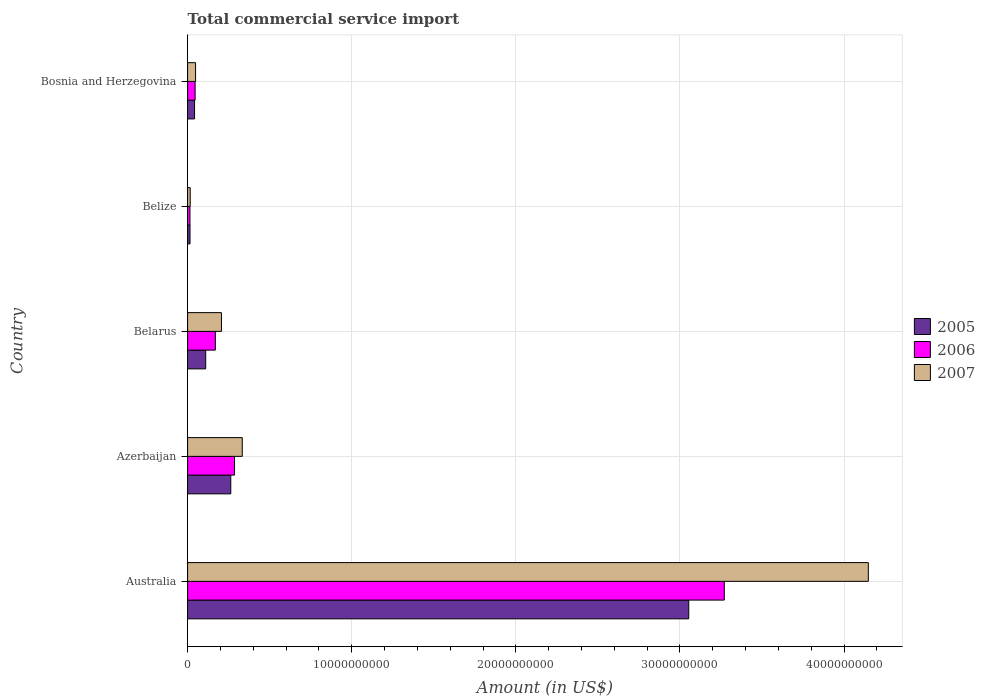How many groups of bars are there?
Offer a very short reply. 5. Are the number of bars on each tick of the Y-axis equal?
Your answer should be compact. Yes. How many bars are there on the 1st tick from the top?
Offer a terse response. 3. What is the label of the 2nd group of bars from the top?
Keep it short and to the point. Belize. In how many cases, is the number of bars for a given country not equal to the number of legend labels?
Make the answer very short. 0. What is the total commercial service import in 2005 in Bosnia and Herzegovina?
Your answer should be very brief. 4.25e+08. Across all countries, what is the maximum total commercial service import in 2007?
Give a very brief answer. 4.15e+1. Across all countries, what is the minimum total commercial service import in 2005?
Offer a very short reply. 1.47e+08. In which country was the total commercial service import in 2006 maximum?
Offer a terse response. Australia. In which country was the total commercial service import in 2007 minimum?
Provide a succinct answer. Belize. What is the total total commercial service import in 2005 in the graph?
Provide a short and direct response. 3.48e+1. What is the difference between the total commercial service import in 2005 in Azerbaijan and that in Bosnia and Herzegovina?
Offer a very short reply. 2.21e+09. What is the difference between the total commercial service import in 2007 in Belize and the total commercial service import in 2006 in Azerbaijan?
Offer a terse response. -2.70e+09. What is the average total commercial service import in 2005 per country?
Your answer should be very brief. 6.97e+09. What is the difference between the total commercial service import in 2005 and total commercial service import in 2007 in Azerbaijan?
Your answer should be compact. -7.00e+08. In how many countries, is the total commercial service import in 2006 greater than 10000000000 US$?
Offer a terse response. 1. What is the ratio of the total commercial service import in 2006 in Australia to that in Bosnia and Herzegovina?
Offer a terse response. 71.39. Is the total commercial service import in 2005 in Belarus less than that in Bosnia and Herzegovina?
Keep it short and to the point. No. What is the difference between the highest and the second highest total commercial service import in 2005?
Give a very brief answer. 2.79e+1. What is the difference between the highest and the lowest total commercial service import in 2005?
Ensure brevity in your answer.  3.04e+1. Is the sum of the total commercial service import in 2006 in Australia and Belarus greater than the maximum total commercial service import in 2005 across all countries?
Make the answer very short. Yes. How many bars are there?
Your answer should be very brief. 15. What is the difference between two consecutive major ticks on the X-axis?
Your answer should be compact. 1.00e+1. Does the graph contain any zero values?
Offer a very short reply. No. Does the graph contain grids?
Make the answer very short. Yes. How many legend labels are there?
Ensure brevity in your answer.  3. What is the title of the graph?
Keep it short and to the point. Total commercial service import. What is the label or title of the X-axis?
Provide a succinct answer. Amount (in US$). What is the Amount (in US$) of 2005 in Australia?
Offer a very short reply. 3.05e+1. What is the Amount (in US$) of 2006 in Australia?
Ensure brevity in your answer.  3.27e+1. What is the Amount (in US$) in 2007 in Australia?
Ensure brevity in your answer.  4.15e+1. What is the Amount (in US$) in 2005 in Azerbaijan?
Provide a short and direct response. 2.63e+09. What is the Amount (in US$) in 2006 in Azerbaijan?
Your answer should be very brief. 2.86e+09. What is the Amount (in US$) in 2007 in Azerbaijan?
Keep it short and to the point. 3.33e+09. What is the Amount (in US$) of 2005 in Belarus?
Give a very brief answer. 1.10e+09. What is the Amount (in US$) in 2006 in Belarus?
Make the answer very short. 1.69e+09. What is the Amount (in US$) in 2007 in Belarus?
Make the answer very short. 2.06e+09. What is the Amount (in US$) in 2005 in Belize?
Keep it short and to the point. 1.47e+08. What is the Amount (in US$) of 2006 in Belize?
Provide a short and direct response. 1.43e+08. What is the Amount (in US$) in 2007 in Belize?
Offer a very short reply. 1.59e+08. What is the Amount (in US$) in 2005 in Bosnia and Herzegovina?
Make the answer very short. 4.25e+08. What is the Amount (in US$) of 2006 in Bosnia and Herzegovina?
Your answer should be very brief. 4.58e+08. What is the Amount (in US$) in 2007 in Bosnia and Herzegovina?
Provide a short and direct response. 4.87e+08. Across all countries, what is the maximum Amount (in US$) of 2005?
Your answer should be very brief. 3.05e+1. Across all countries, what is the maximum Amount (in US$) in 2006?
Make the answer very short. 3.27e+1. Across all countries, what is the maximum Amount (in US$) of 2007?
Give a very brief answer. 4.15e+1. Across all countries, what is the minimum Amount (in US$) of 2005?
Offer a terse response. 1.47e+08. Across all countries, what is the minimum Amount (in US$) in 2006?
Give a very brief answer. 1.43e+08. Across all countries, what is the minimum Amount (in US$) of 2007?
Ensure brevity in your answer.  1.59e+08. What is the total Amount (in US$) in 2005 in the graph?
Keep it short and to the point. 3.48e+1. What is the total Amount (in US$) in 2006 in the graph?
Give a very brief answer. 3.79e+1. What is the total Amount (in US$) of 2007 in the graph?
Make the answer very short. 4.75e+1. What is the difference between the Amount (in US$) of 2005 in Australia and that in Azerbaijan?
Ensure brevity in your answer.  2.79e+1. What is the difference between the Amount (in US$) in 2006 in Australia and that in Azerbaijan?
Provide a succinct answer. 2.98e+1. What is the difference between the Amount (in US$) in 2007 in Australia and that in Azerbaijan?
Your answer should be very brief. 3.81e+1. What is the difference between the Amount (in US$) of 2005 in Australia and that in Belarus?
Your answer should be compact. 2.94e+1. What is the difference between the Amount (in US$) in 2006 in Australia and that in Belarus?
Your answer should be compact. 3.10e+1. What is the difference between the Amount (in US$) of 2007 in Australia and that in Belarus?
Offer a terse response. 3.94e+1. What is the difference between the Amount (in US$) of 2005 in Australia and that in Belize?
Keep it short and to the point. 3.04e+1. What is the difference between the Amount (in US$) in 2006 in Australia and that in Belize?
Make the answer very short. 3.26e+1. What is the difference between the Amount (in US$) in 2007 in Australia and that in Belize?
Make the answer very short. 4.13e+1. What is the difference between the Amount (in US$) in 2005 in Australia and that in Bosnia and Herzegovina?
Offer a terse response. 3.01e+1. What is the difference between the Amount (in US$) of 2006 in Australia and that in Bosnia and Herzegovina?
Provide a succinct answer. 3.22e+1. What is the difference between the Amount (in US$) of 2007 in Australia and that in Bosnia and Herzegovina?
Make the answer very short. 4.10e+1. What is the difference between the Amount (in US$) in 2005 in Azerbaijan and that in Belarus?
Your answer should be very brief. 1.53e+09. What is the difference between the Amount (in US$) in 2006 in Azerbaijan and that in Belarus?
Your response must be concise. 1.17e+09. What is the difference between the Amount (in US$) in 2007 in Azerbaijan and that in Belarus?
Provide a short and direct response. 1.27e+09. What is the difference between the Amount (in US$) in 2005 in Azerbaijan and that in Belize?
Keep it short and to the point. 2.48e+09. What is the difference between the Amount (in US$) of 2006 in Azerbaijan and that in Belize?
Offer a very short reply. 2.72e+09. What is the difference between the Amount (in US$) in 2007 in Azerbaijan and that in Belize?
Make the answer very short. 3.17e+09. What is the difference between the Amount (in US$) in 2005 in Azerbaijan and that in Bosnia and Herzegovina?
Your answer should be very brief. 2.21e+09. What is the difference between the Amount (in US$) in 2006 in Azerbaijan and that in Bosnia and Herzegovina?
Your answer should be very brief. 2.40e+09. What is the difference between the Amount (in US$) in 2007 in Azerbaijan and that in Bosnia and Herzegovina?
Offer a terse response. 2.84e+09. What is the difference between the Amount (in US$) of 2005 in Belarus and that in Belize?
Offer a terse response. 9.57e+08. What is the difference between the Amount (in US$) of 2006 in Belarus and that in Belize?
Offer a terse response. 1.55e+09. What is the difference between the Amount (in US$) of 2007 in Belarus and that in Belize?
Your answer should be very brief. 1.90e+09. What is the difference between the Amount (in US$) of 2005 in Belarus and that in Bosnia and Herzegovina?
Make the answer very short. 6.79e+08. What is the difference between the Amount (in US$) of 2006 in Belarus and that in Bosnia and Herzegovina?
Your answer should be very brief. 1.23e+09. What is the difference between the Amount (in US$) of 2007 in Belarus and that in Bosnia and Herzegovina?
Your response must be concise. 1.58e+09. What is the difference between the Amount (in US$) of 2005 in Belize and that in Bosnia and Herzegovina?
Your answer should be very brief. -2.78e+08. What is the difference between the Amount (in US$) in 2006 in Belize and that in Bosnia and Herzegovina?
Your answer should be compact. -3.15e+08. What is the difference between the Amount (in US$) in 2007 in Belize and that in Bosnia and Herzegovina?
Your answer should be very brief. -3.28e+08. What is the difference between the Amount (in US$) of 2005 in Australia and the Amount (in US$) of 2006 in Azerbaijan?
Ensure brevity in your answer.  2.77e+1. What is the difference between the Amount (in US$) in 2005 in Australia and the Amount (in US$) in 2007 in Azerbaijan?
Offer a terse response. 2.72e+1. What is the difference between the Amount (in US$) of 2006 in Australia and the Amount (in US$) of 2007 in Azerbaijan?
Provide a succinct answer. 2.94e+1. What is the difference between the Amount (in US$) in 2005 in Australia and the Amount (in US$) in 2006 in Belarus?
Provide a short and direct response. 2.88e+1. What is the difference between the Amount (in US$) of 2005 in Australia and the Amount (in US$) of 2007 in Belarus?
Offer a very short reply. 2.85e+1. What is the difference between the Amount (in US$) of 2006 in Australia and the Amount (in US$) of 2007 in Belarus?
Your response must be concise. 3.06e+1. What is the difference between the Amount (in US$) of 2005 in Australia and the Amount (in US$) of 2006 in Belize?
Give a very brief answer. 3.04e+1. What is the difference between the Amount (in US$) in 2005 in Australia and the Amount (in US$) in 2007 in Belize?
Offer a terse response. 3.04e+1. What is the difference between the Amount (in US$) in 2006 in Australia and the Amount (in US$) in 2007 in Belize?
Ensure brevity in your answer.  3.25e+1. What is the difference between the Amount (in US$) in 2005 in Australia and the Amount (in US$) in 2006 in Bosnia and Herzegovina?
Ensure brevity in your answer.  3.01e+1. What is the difference between the Amount (in US$) of 2005 in Australia and the Amount (in US$) of 2007 in Bosnia and Herzegovina?
Keep it short and to the point. 3.00e+1. What is the difference between the Amount (in US$) of 2006 in Australia and the Amount (in US$) of 2007 in Bosnia and Herzegovina?
Provide a succinct answer. 3.22e+1. What is the difference between the Amount (in US$) in 2005 in Azerbaijan and the Amount (in US$) in 2006 in Belarus?
Ensure brevity in your answer.  9.40e+08. What is the difference between the Amount (in US$) in 2005 in Azerbaijan and the Amount (in US$) in 2007 in Belarus?
Ensure brevity in your answer.  5.68e+08. What is the difference between the Amount (in US$) in 2006 in Azerbaijan and the Amount (in US$) in 2007 in Belarus?
Offer a very short reply. 7.97e+08. What is the difference between the Amount (in US$) in 2005 in Azerbaijan and the Amount (in US$) in 2006 in Belize?
Your answer should be very brief. 2.49e+09. What is the difference between the Amount (in US$) in 2005 in Azerbaijan and the Amount (in US$) in 2007 in Belize?
Offer a terse response. 2.47e+09. What is the difference between the Amount (in US$) of 2006 in Azerbaijan and the Amount (in US$) of 2007 in Belize?
Offer a terse response. 2.70e+09. What is the difference between the Amount (in US$) of 2005 in Azerbaijan and the Amount (in US$) of 2006 in Bosnia and Herzegovina?
Your answer should be very brief. 2.17e+09. What is the difference between the Amount (in US$) in 2005 in Azerbaijan and the Amount (in US$) in 2007 in Bosnia and Herzegovina?
Ensure brevity in your answer.  2.14e+09. What is the difference between the Amount (in US$) in 2006 in Azerbaijan and the Amount (in US$) in 2007 in Bosnia and Herzegovina?
Make the answer very short. 2.37e+09. What is the difference between the Amount (in US$) of 2005 in Belarus and the Amount (in US$) of 2006 in Belize?
Provide a succinct answer. 9.61e+08. What is the difference between the Amount (in US$) of 2005 in Belarus and the Amount (in US$) of 2007 in Belize?
Offer a very short reply. 9.45e+08. What is the difference between the Amount (in US$) of 2006 in Belarus and the Amount (in US$) of 2007 in Belize?
Keep it short and to the point. 1.53e+09. What is the difference between the Amount (in US$) in 2005 in Belarus and the Amount (in US$) in 2006 in Bosnia and Herzegovina?
Keep it short and to the point. 6.46e+08. What is the difference between the Amount (in US$) of 2005 in Belarus and the Amount (in US$) of 2007 in Bosnia and Herzegovina?
Give a very brief answer. 6.18e+08. What is the difference between the Amount (in US$) of 2006 in Belarus and the Amount (in US$) of 2007 in Bosnia and Herzegovina?
Give a very brief answer. 1.20e+09. What is the difference between the Amount (in US$) in 2005 in Belize and the Amount (in US$) in 2006 in Bosnia and Herzegovina?
Provide a short and direct response. -3.11e+08. What is the difference between the Amount (in US$) of 2005 in Belize and the Amount (in US$) of 2007 in Bosnia and Herzegovina?
Offer a very short reply. -3.39e+08. What is the difference between the Amount (in US$) of 2006 in Belize and the Amount (in US$) of 2007 in Bosnia and Herzegovina?
Offer a terse response. -3.43e+08. What is the average Amount (in US$) in 2005 per country?
Provide a short and direct response. 6.97e+09. What is the average Amount (in US$) of 2006 per country?
Your answer should be compact. 7.57e+09. What is the average Amount (in US$) in 2007 per country?
Provide a short and direct response. 9.50e+09. What is the difference between the Amount (in US$) of 2005 and Amount (in US$) of 2006 in Australia?
Your response must be concise. -2.17e+09. What is the difference between the Amount (in US$) in 2005 and Amount (in US$) in 2007 in Australia?
Keep it short and to the point. -1.09e+1. What is the difference between the Amount (in US$) in 2006 and Amount (in US$) in 2007 in Australia?
Keep it short and to the point. -8.78e+09. What is the difference between the Amount (in US$) of 2005 and Amount (in US$) of 2006 in Azerbaijan?
Make the answer very short. -2.28e+08. What is the difference between the Amount (in US$) in 2005 and Amount (in US$) in 2007 in Azerbaijan?
Your answer should be compact. -7.00e+08. What is the difference between the Amount (in US$) in 2006 and Amount (in US$) in 2007 in Azerbaijan?
Your answer should be very brief. -4.72e+08. What is the difference between the Amount (in US$) of 2005 and Amount (in US$) of 2006 in Belarus?
Make the answer very short. -5.87e+08. What is the difference between the Amount (in US$) of 2005 and Amount (in US$) of 2007 in Belarus?
Your response must be concise. -9.58e+08. What is the difference between the Amount (in US$) of 2006 and Amount (in US$) of 2007 in Belarus?
Offer a terse response. -3.72e+08. What is the difference between the Amount (in US$) in 2005 and Amount (in US$) in 2006 in Belize?
Keep it short and to the point. 3.89e+06. What is the difference between the Amount (in US$) of 2005 and Amount (in US$) of 2007 in Belize?
Provide a succinct answer. -1.18e+07. What is the difference between the Amount (in US$) in 2006 and Amount (in US$) in 2007 in Belize?
Provide a succinct answer. -1.57e+07. What is the difference between the Amount (in US$) of 2005 and Amount (in US$) of 2006 in Bosnia and Herzegovina?
Keep it short and to the point. -3.32e+07. What is the difference between the Amount (in US$) in 2005 and Amount (in US$) in 2007 in Bosnia and Herzegovina?
Provide a succinct answer. -6.18e+07. What is the difference between the Amount (in US$) in 2006 and Amount (in US$) in 2007 in Bosnia and Herzegovina?
Ensure brevity in your answer.  -2.86e+07. What is the ratio of the Amount (in US$) of 2005 in Australia to that in Azerbaijan?
Give a very brief answer. 11.61. What is the ratio of the Amount (in US$) of 2006 in Australia to that in Azerbaijan?
Give a very brief answer. 11.44. What is the ratio of the Amount (in US$) in 2007 in Australia to that in Azerbaijan?
Your response must be concise. 12.45. What is the ratio of the Amount (in US$) in 2005 in Australia to that in Belarus?
Your response must be concise. 27.65. What is the ratio of the Amount (in US$) of 2006 in Australia to that in Belarus?
Your answer should be compact. 19.34. What is the ratio of the Amount (in US$) in 2007 in Australia to that in Belarus?
Provide a short and direct response. 20.11. What is the ratio of the Amount (in US$) in 2005 in Australia to that in Belize?
Your answer should be compact. 207.45. What is the ratio of the Amount (in US$) in 2006 in Australia to that in Belize?
Your answer should be very brief. 228.19. What is the ratio of the Amount (in US$) of 2007 in Australia to that in Belize?
Your answer should be compact. 260.86. What is the ratio of the Amount (in US$) in 2005 in Australia to that in Bosnia and Herzegovina?
Keep it short and to the point. 71.87. What is the ratio of the Amount (in US$) in 2006 in Australia to that in Bosnia and Herzegovina?
Give a very brief answer. 71.39. What is the ratio of the Amount (in US$) of 2007 in Australia to that in Bosnia and Herzegovina?
Your answer should be compact. 85.23. What is the ratio of the Amount (in US$) in 2005 in Azerbaijan to that in Belarus?
Give a very brief answer. 2.38. What is the ratio of the Amount (in US$) of 2006 in Azerbaijan to that in Belarus?
Your answer should be very brief. 1.69. What is the ratio of the Amount (in US$) in 2007 in Azerbaijan to that in Belarus?
Your answer should be very brief. 1.61. What is the ratio of the Amount (in US$) in 2005 in Azerbaijan to that in Belize?
Offer a terse response. 17.87. What is the ratio of the Amount (in US$) of 2006 in Azerbaijan to that in Belize?
Provide a succinct answer. 19.95. What is the ratio of the Amount (in US$) in 2007 in Azerbaijan to that in Belize?
Offer a very short reply. 20.95. What is the ratio of the Amount (in US$) of 2005 in Azerbaijan to that in Bosnia and Herzegovina?
Ensure brevity in your answer.  6.19. What is the ratio of the Amount (in US$) of 2006 in Azerbaijan to that in Bosnia and Herzegovina?
Provide a succinct answer. 6.24. What is the ratio of the Amount (in US$) of 2007 in Azerbaijan to that in Bosnia and Herzegovina?
Your response must be concise. 6.85. What is the ratio of the Amount (in US$) in 2005 in Belarus to that in Belize?
Keep it short and to the point. 7.5. What is the ratio of the Amount (in US$) in 2006 in Belarus to that in Belize?
Provide a succinct answer. 11.8. What is the ratio of the Amount (in US$) in 2007 in Belarus to that in Belize?
Your answer should be very brief. 12.97. What is the ratio of the Amount (in US$) of 2005 in Belarus to that in Bosnia and Herzegovina?
Your answer should be very brief. 2.6. What is the ratio of the Amount (in US$) in 2006 in Belarus to that in Bosnia and Herzegovina?
Offer a very short reply. 3.69. What is the ratio of the Amount (in US$) of 2007 in Belarus to that in Bosnia and Herzegovina?
Offer a very short reply. 4.24. What is the ratio of the Amount (in US$) of 2005 in Belize to that in Bosnia and Herzegovina?
Make the answer very short. 0.35. What is the ratio of the Amount (in US$) of 2006 in Belize to that in Bosnia and Herzegovina?
Your answer should be very brief. 0.31. What is the ratio of the Amount (in US$) in 2007 in Belize to that in Bosnia and Herzegovina?
Make the answer very short. 0.33. What is the difference between the highest and the second highest Amount (in US$) of 2005?
Keep it short and to the point. 2.79e+1. What is the difference between the highest and the second highest Amount (in US$) of 2006?
Offer a terse response. 2.98e+1. What is the difference between the highest and the second highest Amount (in US$) in 2007?
Your answer should be very brief. 3.81e+1. What is the difference between the highest and the lowest Amount (in US$) in 2005?
Provide a short and direct response. 3.04e+1. What is the difference between the highest and the lowest Amount (in US$) in 2006?
Keep it short and to the point. 3.26e+1. What is the difference between the highest and the lowest Amount (in US$) of 2007?
Give a very brief answer. 4.13e+1. 